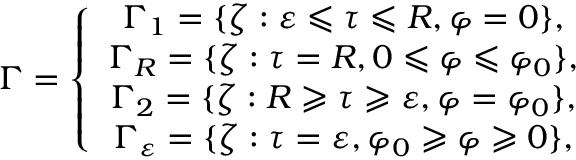<formula> <loc_0><loc_0><loc_500><loc_500>\Gamma = \left \{ \begin{array} { c } { \Gamma _ { 1 } = \{ \zeta \colon \varepsilon \leqslant \tau \leqslant R , \varphi = 0 \} , } \\ { \Gamma _ { R } = \{ \zeta \colon \tau = R , 0 \leqslant \varphi \leqslant \varphi _ { 0 } \} , } \\ { \Gamma _ { 2 } = \{ \zeta \colon R \geqslant \tau \geqslant \varepsilon , \varphi = \varphi _ { 0 } \} , } \\ { \Gamma _ { \varepsilon } = \{ \zeta \colon \tau = \varepsilon , \varphi _ { 0 } \geqslant \varphi \geqslant 0 \} , } \end{array}</formula> 